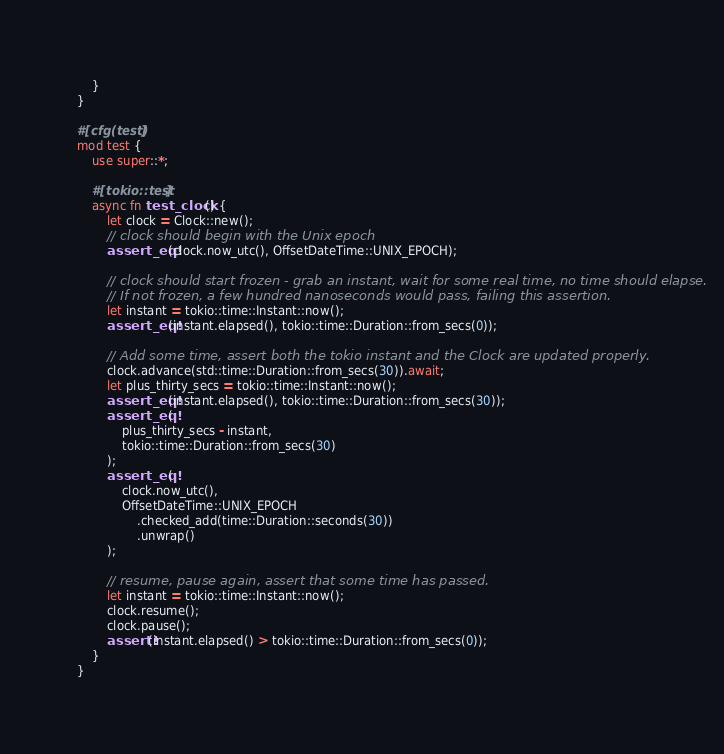Convert code to text. <code><loc_0><loc_0><loc_500><loc_500><_Rust_>	}
}

#[cfg(test)]
mod test {
	use super::*;

	#[tokio::test]
	async fn test_clock() {
		let clock = Clock::new();
		// clock should begin with the Unix epoch
		assert_eq!(clock.now_utc(), OffsetDateTime::UNIX_EPOCH);

		// clock should start frozen - grab an instant, wait for some real time, no time should elapse.
		// If not frozen, a few hundred nanoseconds would pass, failing this assertion.
		let instant = tokio::time::Instant::now();
		assert_eq!(instant.elapsed(), tokio::time::Duration::from_secs(0));

		// Add some time, assert both the tokio instant and the Clock are updated properly.
		clock.advance(std::time::Duration::from_secs(30)).await;
		let plus_thirty_secs = tokio::time::Instant::now();
		assert_eq!(instant.elapsed(), tokio::time::Duration::from_secs(30));
		assert_eq!(
			plus_thirty_secs - instant,
			tokio::time::Duration::from_secs(30)
		);
		assert_eq!(
			clock.now_utc(),
			OffsetDateTime::UNIX_EPOCH
				.checked_add(time::Duration::seconds(30))
				.unwrap()
		);

		// resume, pause again, assert that some time has passed.
		let instant = tokio::time::Instant::now();
		clock.resume();
		clock.pause();
		assert!(instant.elapsed() > tokio::time::Duration::from_secs(0));
	}
}
</code> 